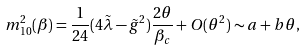<formula> <loc_0><loc_0><loc_500><loc_500>m _ { 1 0 } ^ { 2 } ( \beta ) = \frac { 1 } { 2 4 } ( 4 \tilde { \lambda } - \tilde { g } ^ { 2 } ) \frac { 2 \theta } { \beta _ { c } } + O ( \theta ^ { 2 } ) \sim a + b \theta ,</formula> 